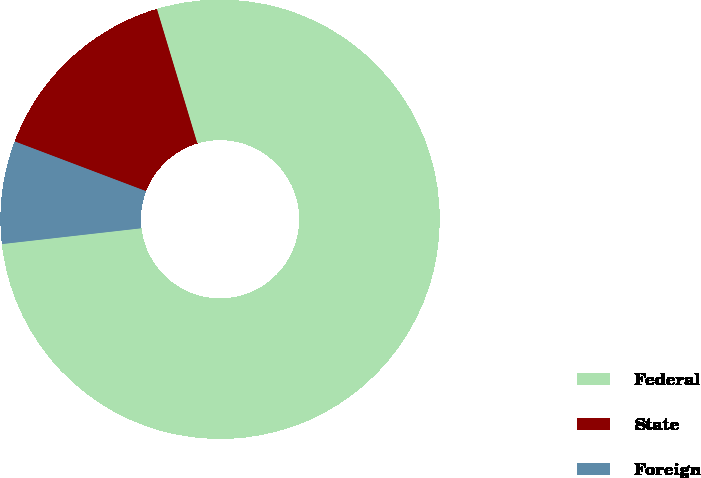Convert chart to OTSL. <chart><loc_0><loc_0><loc_500><loc_500><pie_chart><fcel>Federal<fcel>State<fcel>Foreign<nl><fcel>77.85%<fcel>14.59%<fcel>7.56%<nl></chart> 